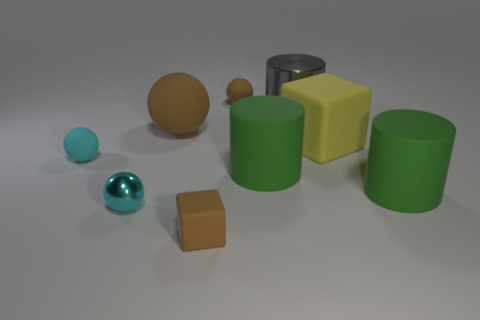Can you describe the textures of the objects? Certainly. The cyan spheres have a shiny, reflective surface, indicating they are likely made of a smooth, glossy material, such as plastic or glass. The yellow cube and green cylinders have a matte finish, suggesting a more rough or porous texture, like painted wood or plastic. The brown objects, a sphere and a cube, exhibit a less reflective surface which could imply a material like clay or uncoated wood. 